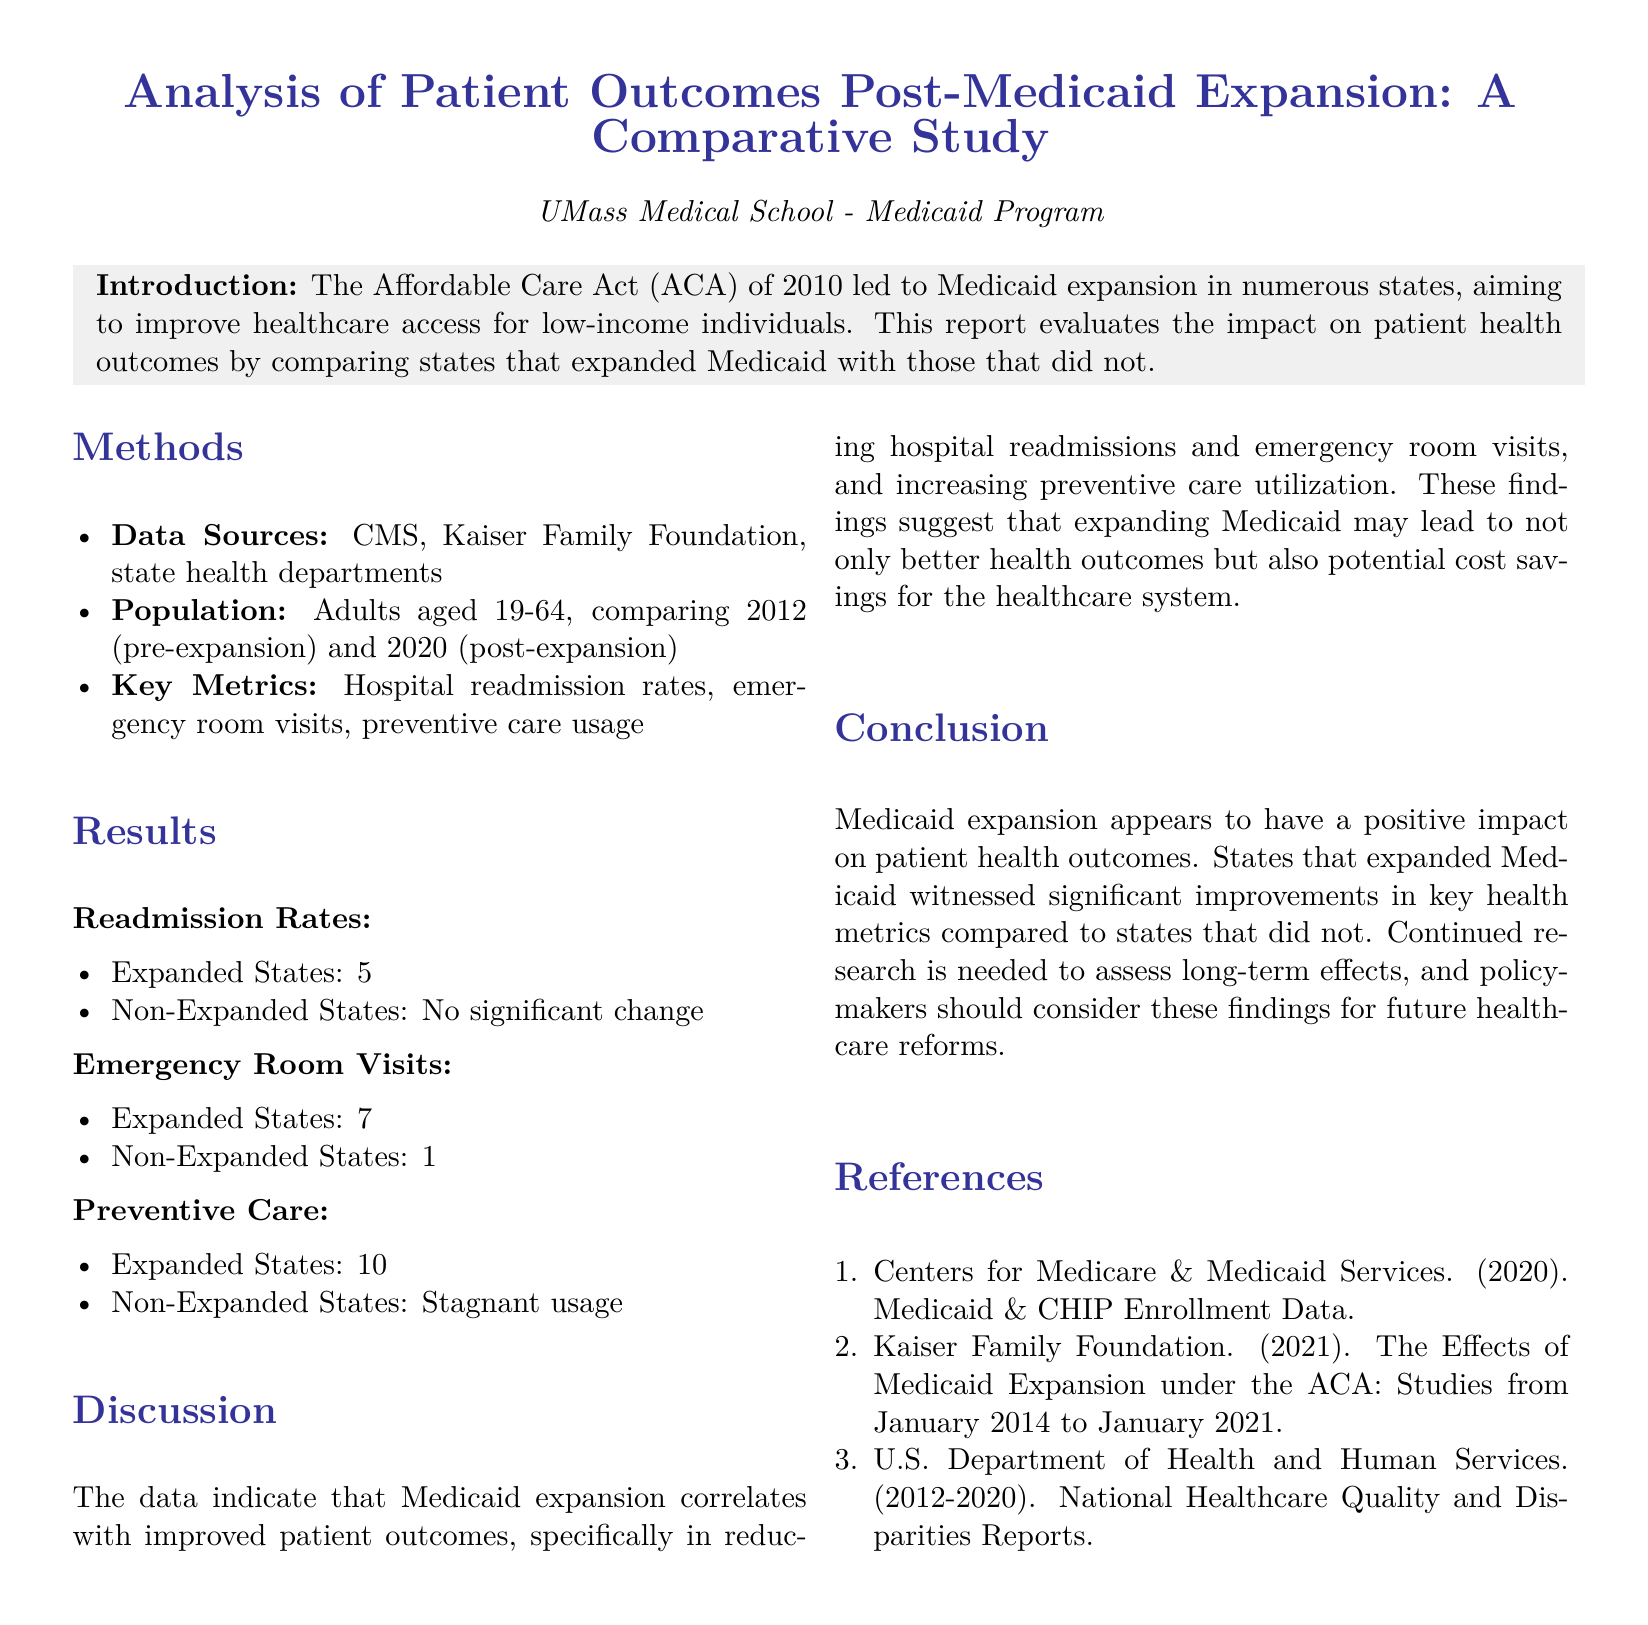what was the average drop in readmission rates for expanded states from 2012 to 2020? The report states that there was a 5% average drop in readmission rates in expanded states between 2012 and 2020.
Answer: 5% what percentage decrease was reported in emergency room visits for expanded states? According to the results, the decrease in emergency room visits for expanded states was 7%.
Answer: 7% which health metrics showed improvement in states that expanded Medicaid? The discussion mentions that hospital readmissions, emergency room visits, and preventive care utilization improved in expanded states.
Answer: hospital readmissions, emergency room visits, preventive care utilization what was the increase in preventive care usage in expanded states? The report indicates that there was a 10% increase in preventive care usage in expanded states.
Answer: 10% what was the key argument in the conclusion regarding Medicaid expansion? The conclusion suggests that Medicaid expansion has a positive impact on patient health outcomes, which is a primary focus of the report.
Answer: positive impact on patient health outcomes how many references are listed in the report? There are three references listed in the report as key sources of information.
Answer: three what are the data sources mentioned in the methods section? The data sources include CMS, Kaiser Family Foundation, and state health departments, as outlined in the methods section.
Answer: CMS, Kaiser Family Foundation, state health departments what years did the population comparison cover in the study? The study compared the population data from the years 2012 and 2020.
Answer: 2012 and 2020 what is the main purpose of the report? The report's main purpose is to evaluate the impact of Medicaid expansion on patient health outcomes by comparing expanded and non-expanded states.
Answer: evaluate the impact of Medicaid expansion on patient health outcomes 